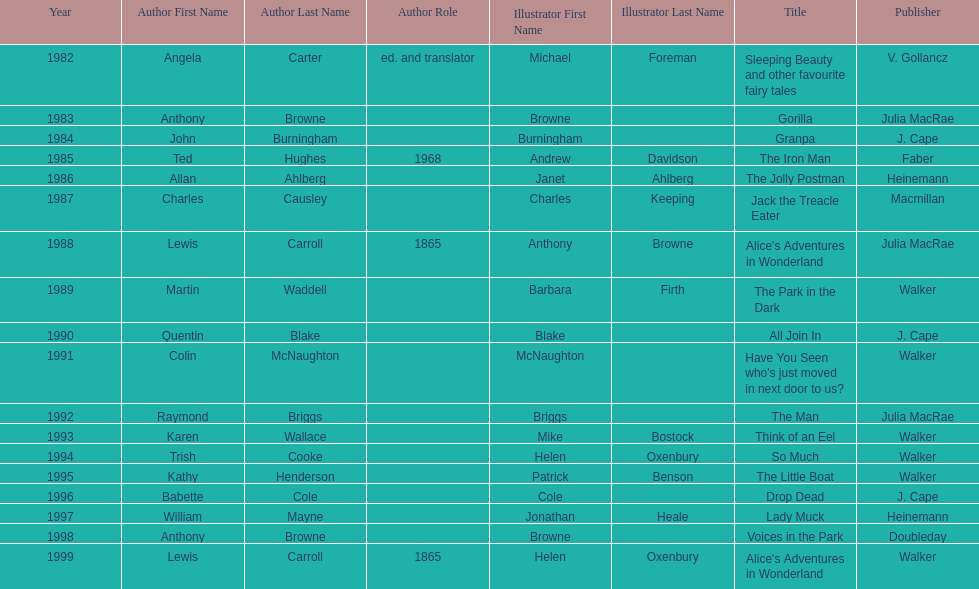Which title was after the year 1991 but before the year 1993? The Man. 